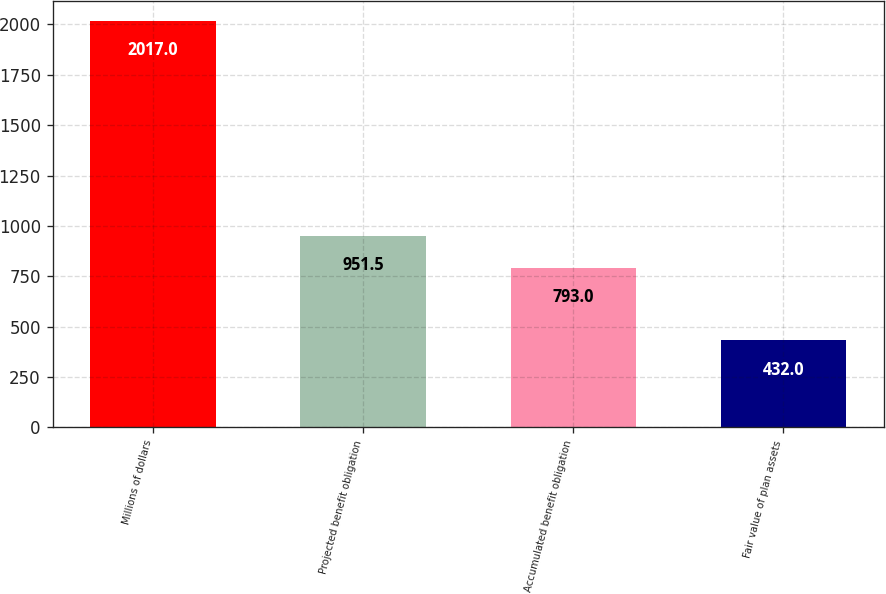Convert chart. <chart><loc_0><loc_0><loc_500><loc_500><bar_chart><fcel>Millions of dollars<fcel>Projected benefit obligation<fcel>Accumulated benefit obligation<fcel>Fair value of plan assets<nl><fcel>2017<fcel>951.5<fcel>793<fcel>432<nl></chart> 